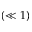Convert formula to latex. <formula><loc_0><loc_0><loc_500><loc_500>( \ll 1 )</formula> 